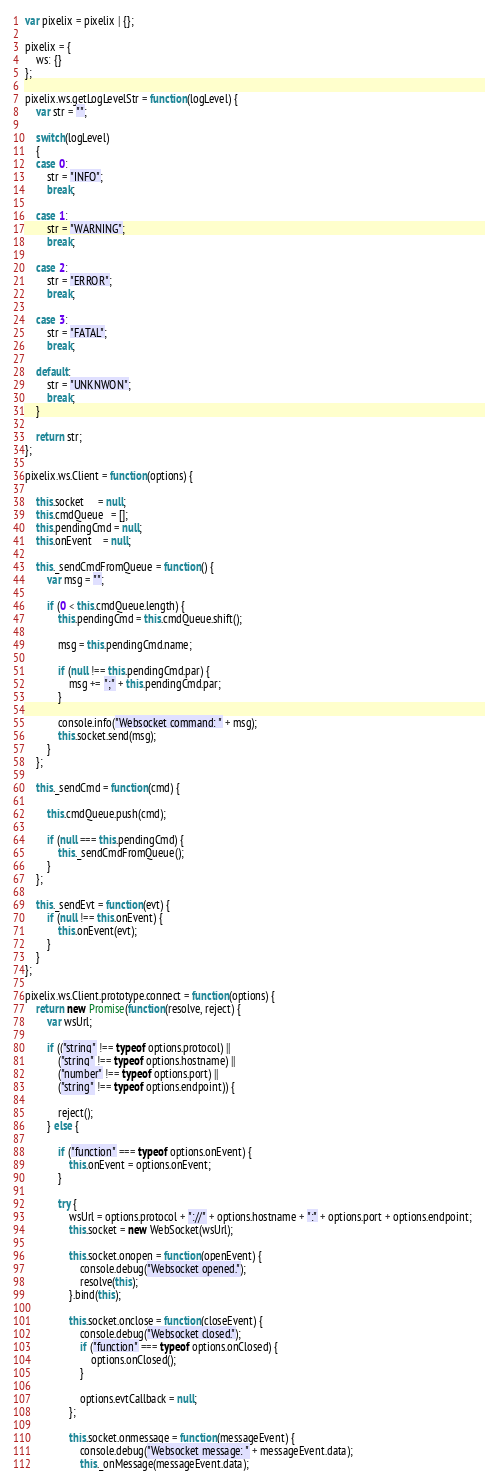<code> <loc_0><loc_0><loc_500><loc_500><_JavaScript_>var pixelix = pixelix | {};

pixelix = {
    ws: {}
};

pixelix.ws.getLogLevelStr = function(logLevel) {
    var str = "";

    switch(logLevel)
    {
    case 0:
        str = "INFO";
        break;

    case 1:
        str = "WARNING";
        break;

    case 2:
        str = "ERROR";
        break;

    case 3:
        str = "FATAL";
        break;

    default:
        str = "UNKNWON";
        break;
    }

    return str;
};

pixelix.ws.Client = function(options) {

    this.socket     = null;
    this.cmdQueue   = [];
    this.pendingCmd = null;
    this.onEvent    = null;

    this._sendCmdFromQueue = function() {
        var msg = "";

        if (0 < this.cmdQueue.length) {
            this.pendingCmd = this.cmdQueue.shift();

            msg = this.pendingCmd.name;

            if (null !== this.pendingCmd.par) {
                msg += ";" + this.pendingCmd.par;
            }

            console.info("Websocket command: " + msg);
            this.socket.send(msg);
        }
    };

    this._sendCmd = function(cmd) {

        this.cmdQueue.push(cmd);

        if (null === this.pendingCmd) {
            this._sendCmdFromQueue();
        }
    };

    this._sendEvt = function(evt) {
        if (null !== this.onEvent) {
            this.onEvent(evt);
        }
    }
};

pixelix.ws.Client.prototype.connect = function(options) {
    return new Promise(function(resolve, reject) {
        var wsUrl;

        if (("string" !== typeof options.protocol) ||
            ("string" !== typeof options.hostname) ||
            ("number" !== typeof options.port) ||
            ("string" !== typeof options.endpoint)) {

            reject();
        } else {

            if ("function" === typeof options.onEvent) {
                this.onEvent = options.onEvent;
            }

            try {
                wsUrl = options.protocol + "://" + options.hostname + ":" + options.port + options.endpoint;
                this.socket = new WebSocket(wsUrl);

                this.socket.onopen = function(openEvent) {
                    console.debug("Websocket opened.");
                    resolve(this);
                }.bind(this);

                this.socket.onclose = function(closeEvent) {
                    console.debug("Websocket closed.");
                    if ("function" === typeof options.onClosed) {
                        options.onClosed();
                    }

                    options.evtCallback = null;
                };

                this.socket.onmessage = function(messageEvent) {
                    console.debug("Websocket message: " + messageEvent.data);
                    this._onMessage(messageEvent.data);</code> 